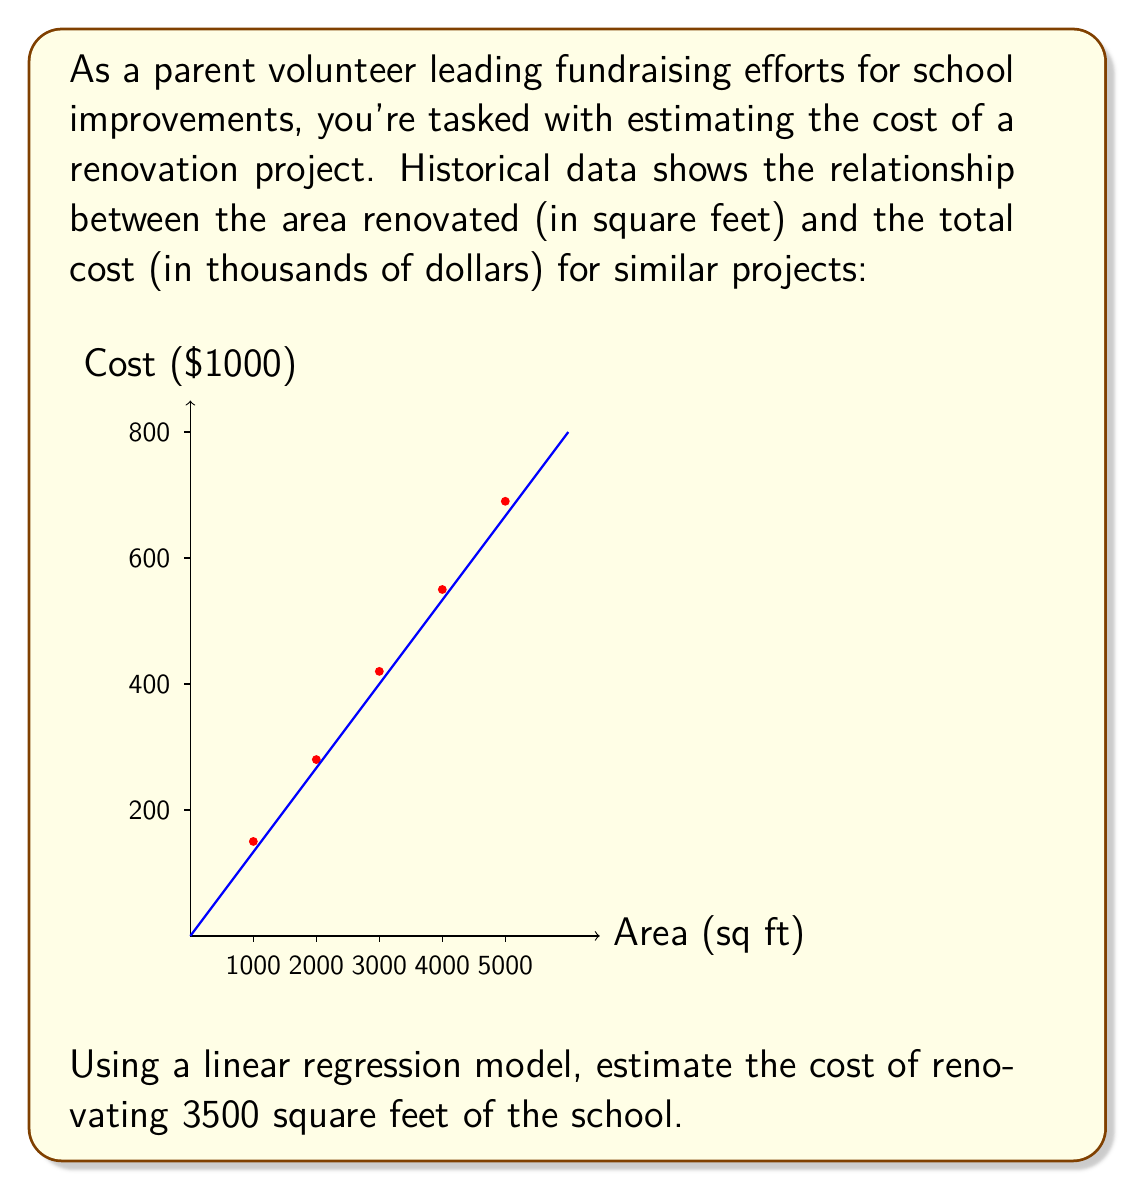Provide a solution to this math problem. To solve this problem, we'll use the linear regression model:

$$ y = mx + b $$

Where $y$ is the cost, $x$ is the area, $m$ is the slope, and $b$ is the y-intercept.

Steps:
1) Calculate the slope $m$ using the formula:
   $$ m = \frac{n\sum xy - \sum x \sum y}{n\sum x^2 - (\sum x)^2} $$

2) Calculate the y-intercept $b$ using:
   $$ b = \bar{y} - m\bar{x} $$
   where $\bar{x}$ and $\bar{y}$ are the means of x and y respectively.

3) Using the given data:
   $\sum x = 15000$, $\sum y = 2090$, $\sum xy = 7,270,000$, $\sum x^2 = 55,000,000$, $n = 5$

4) Plugging into the slope formula:
   $$ m = \frac{5(7,270,000) - 15000(2090)}{5(55,000,000) - 15000^2} = 0.135 $$

5) Calculate means: $\bar{x} = 3000$, $\bar{y} = 418$

6) Calculate y-intercept:
   $$ b = 418 - 0.135(3000) = 13 $$

7) The linear regression equation is:
   $$ y = 0.135x + 13 $$

8) To estimate the cost for 3500 sq ft:
   $$ y = 0.135(3500) + 13 = 485.5 $$

Therefore, the estimated cost is $485,500.
Answer: $485,500 